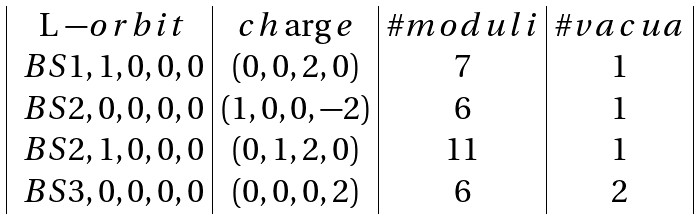<formula> <loc_0><loc_0><loc_500><loc_500>\begin{array} { | c | c | c | c | } $ L $ - o r b i t & c h \arg e & \# m o d u l i & \# v a c u a \\ \ B S { 1 , 1 , 0 , 0 , 0 } & ( 0 , 0 , 2 , 0 ) & 7 & 1 \\ \ B S { 2 , 0 , 0 , 0 , 0 } & ( 1 , 0 , 0 , - 2 ) & 6 & 1 \\ \ B S { 2 , 1 , 0 , 0 , 0 } & ( 0 , 1 , 2 , 0 ) & 1 1 & 1 \\ \ B S { 3 , 0 , 0 , 0 , 0 } & ( 0 , 0 , 0 , 2 ) & 6 & 2 \\ \end{array}</formula> 